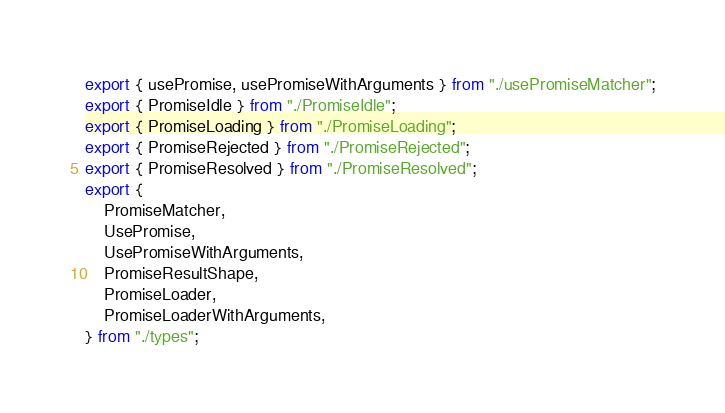Convert code to text. <code><loc_0><loc_0><loc_500><loc_500><_TypeScript_>export { usePromise, usePromiseWithArguments } from "./usePromiseMatcher";
export { PromiseIdle } from "./PromiseIdle";
export { PromiseLoading } from "./PromiseLoading";
export { PromiseRejected } from "./PromiseRejected";
export { PromiseResolved } from "./PromiseResolved";
export {
    PromiseMatcher,
    UsePromise,
    UsePromiseWithArguments,
    PromiseResultShape,
    PromiseLoader,
    PromiseLoaderWithArguments,
} from "./types";
</code> 